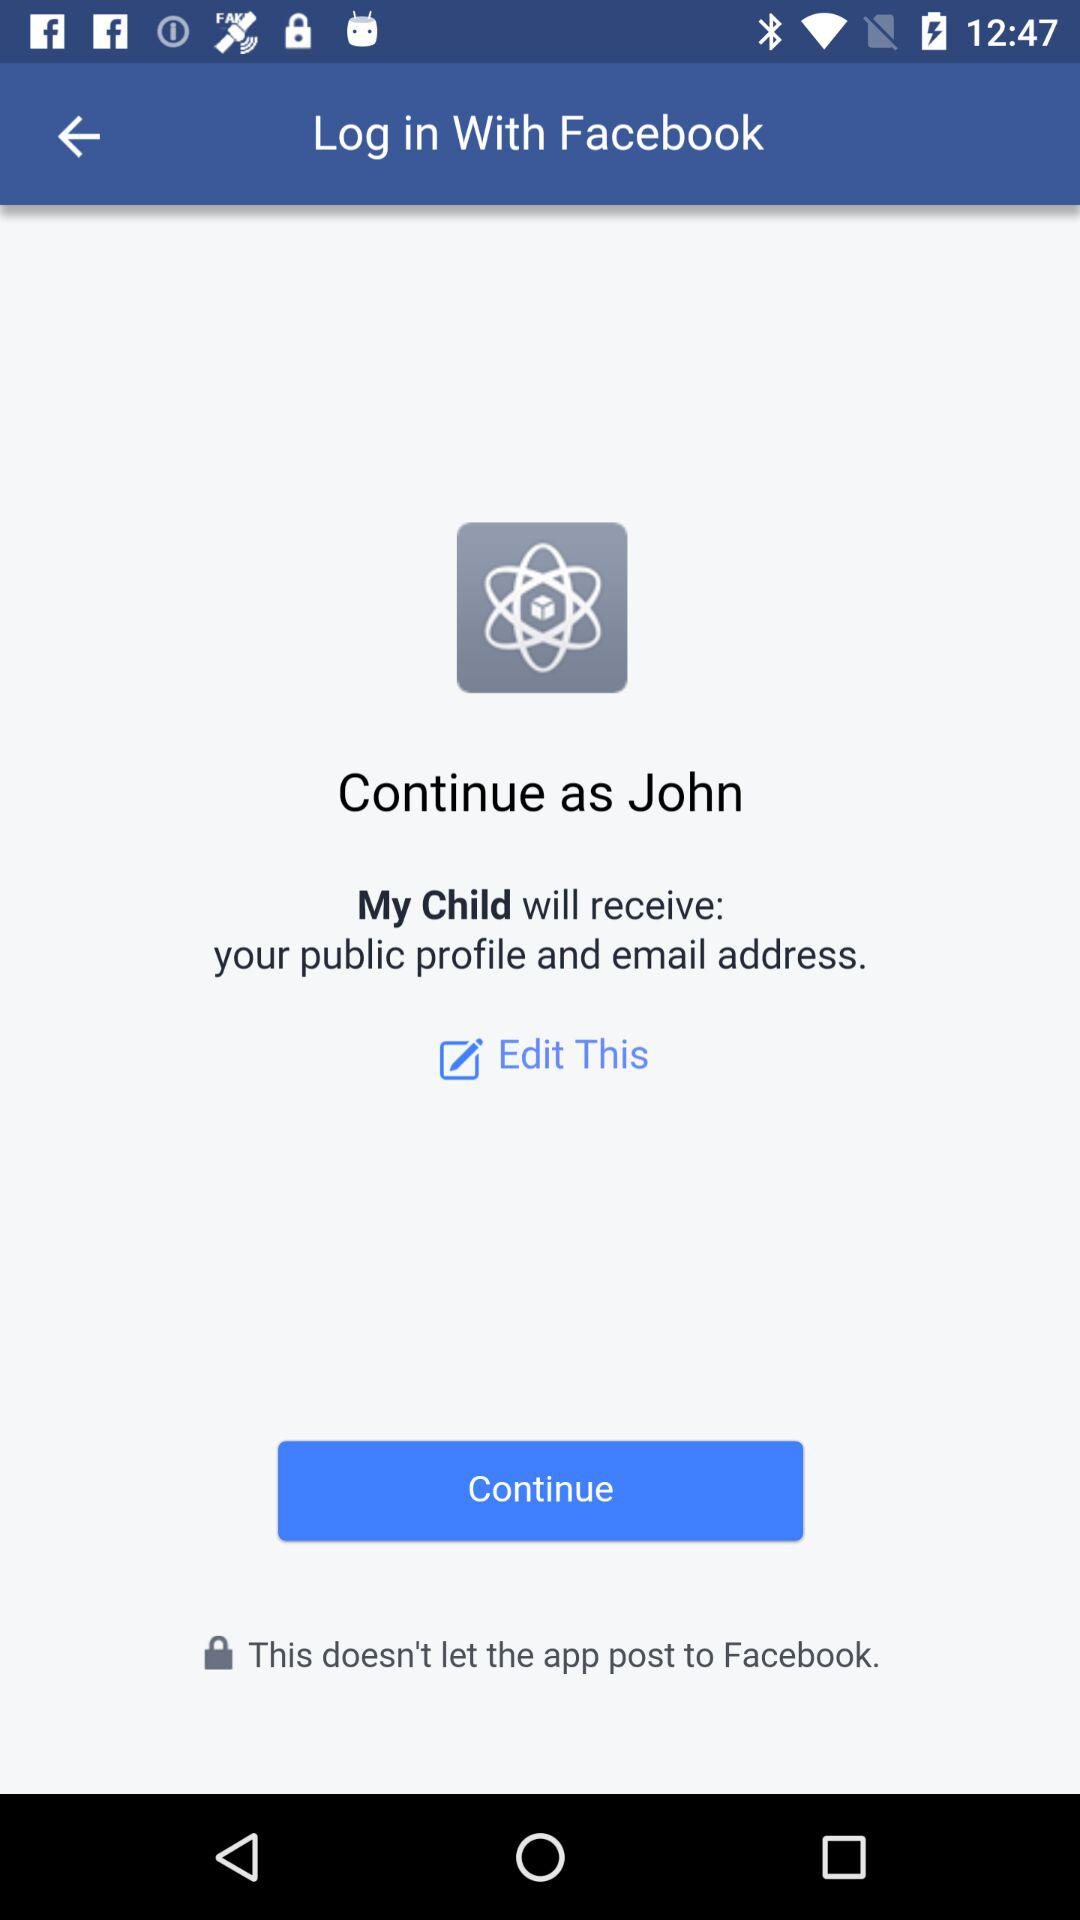What is the name of the user? The name of the user is John. 